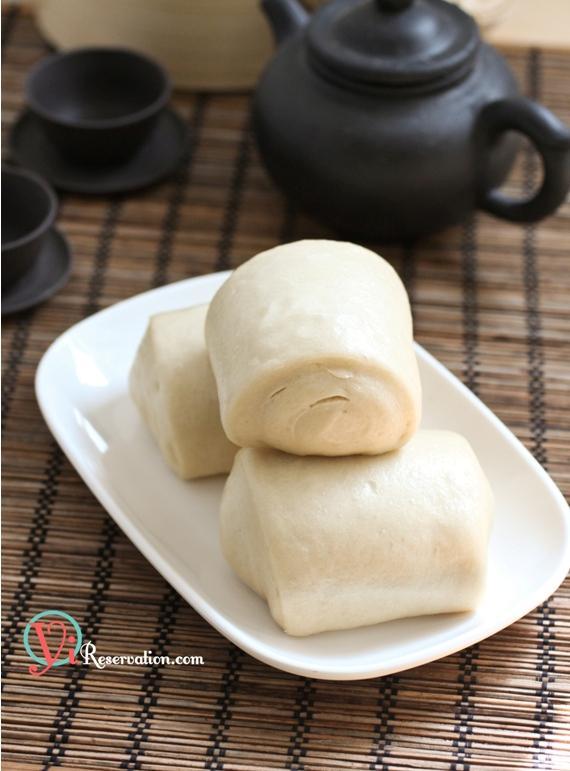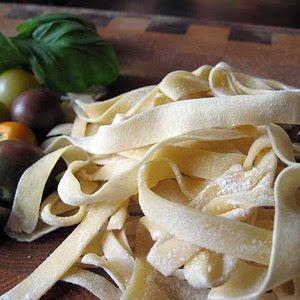The first image is the image on the left, the second image is the image on the right. For the images shown, is this caption "The pasta in the image on the left is sitting atop a dusting of flour." true? Answer yes or no. No. The first image is the image on the left, the second image is the image on the right. For the images displayed, is the sentence "There are at least 10 flat handmade noodles sitting on a wood table." factually correct? Answer yes or no. Yes. 